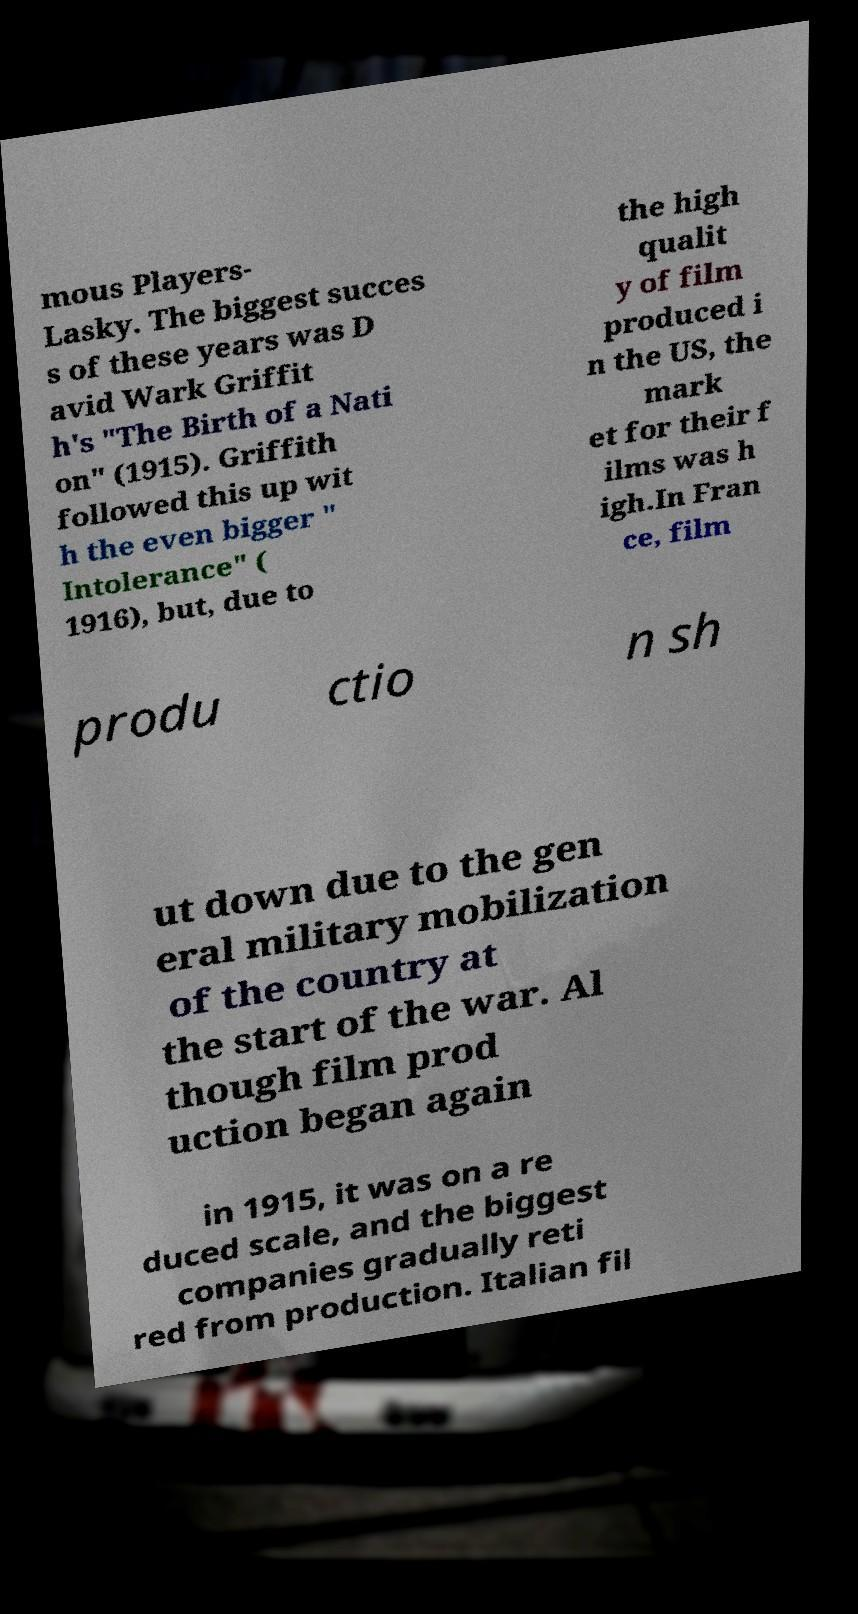Can you accurately transcribe the text from the provided image for me? mous Players- Lasky. The biggest succes s of these years was D avid Wark Griffit h's "The Birth of a Nati on" (1915). Griffith followed this up wit h the even bigger " Intolerance" ( 1916), but, due to the high qualit y of film produced i n the US, the mark et for their f ilms was h igh.In Fran ce, film produ ctio n sh ut down due to the gen eral military mobilization of the country at the start of the war. Al though film prod uction began again in 1915, it was on a re duced scale, and the biggest companies gradually reti red from production. Italian fil 